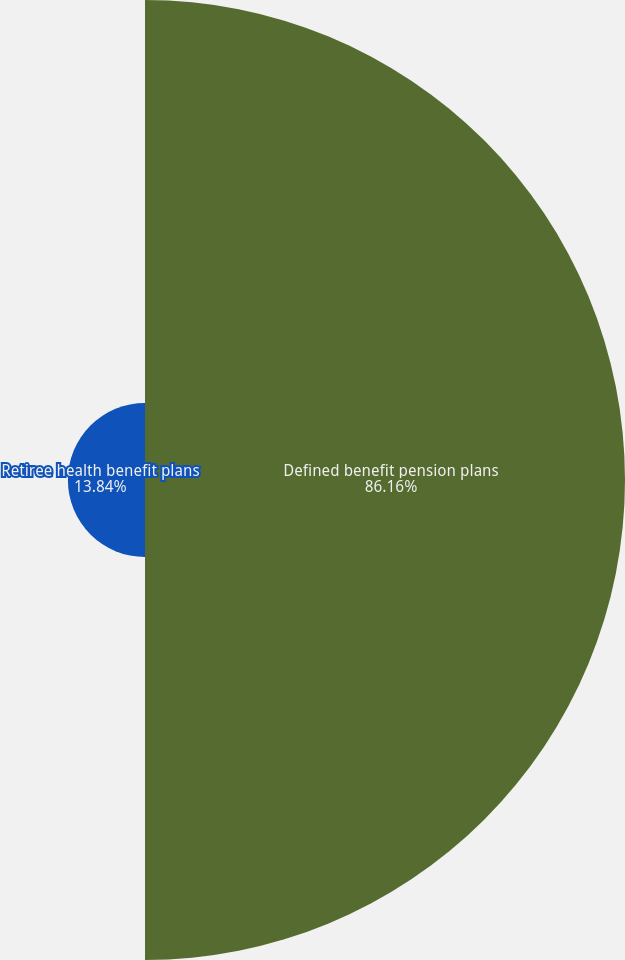Convert chart to OTSL. <chart><loc_0><loc_0><loc_500><loc_500><pie_chart><fcel>Defined benefit pension plans<fcel>Retiree health benefit plans<nl><fcel>86.16%<fcel>13.84%<nl></chart> 